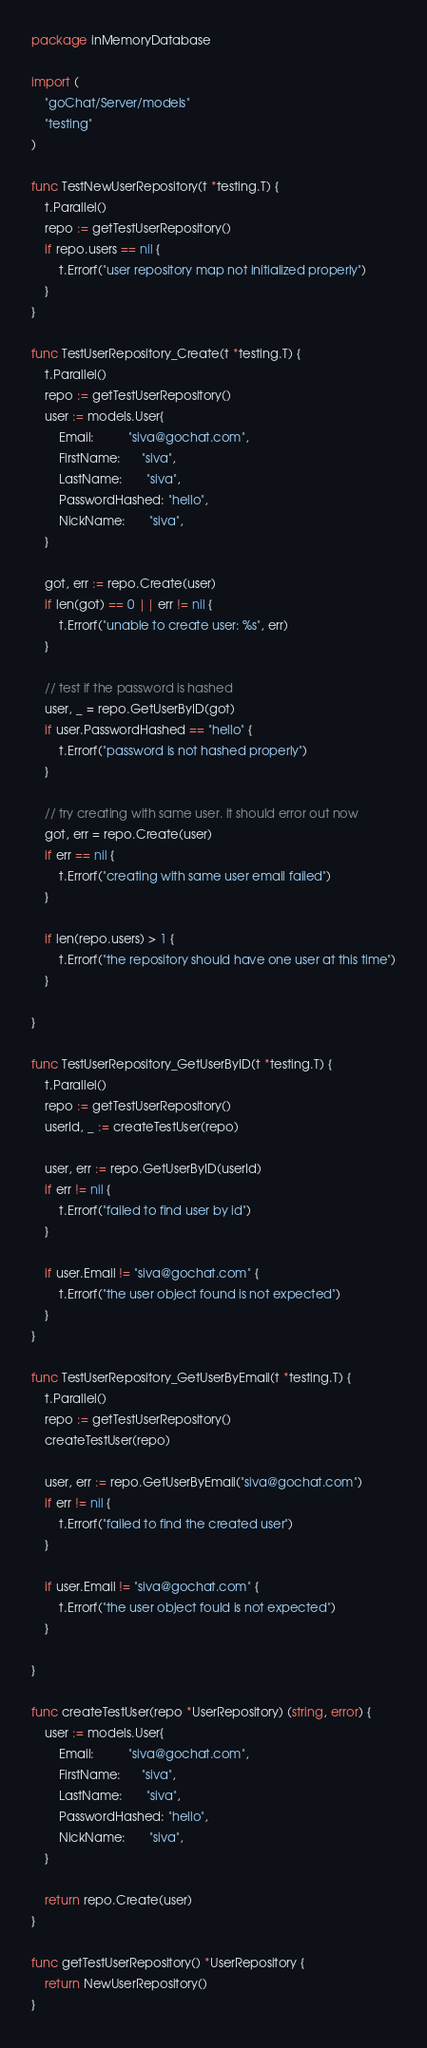Convert code to text. <code><loc_0><loc_0><loc_500><loc_500><_Go_>package inMemoryDatabase

import (
	"goChat/Server/models"
	"testing"
)

func TestNewUserRepository(t *testing.T) {
	t.Parallel()
	repo := getTestUserRepository()
	if repo.users == nil {
		t.Errorf("user repository map not initialized properly")
	}
}

func TestUserRepository_Create(t *testing.T) {
	t.Parallel()
	repo := getTestUserRepository()
	user := models.User{
		Email:          "siva@gochat.com",
		FirstName:      "siva",
		LastName:       "siva",
		PasswordHashed: "hello",
		NickName:       "siva",
	}

	got, err := repo.Create(user)
	if len(got) == 0 || err != nil {
		t.Errorf("unable to create user: %s", err)
	}

	// test if the password is hashed
	user, _ = repo.GetUserByID(got)
	if user.PasswordHashed == "hello" {
		t.Errorf("password is not hashed properly")
	}

	// try creating with same user. it should error out now
	got, err = repo.Create(user)
	if err == nil {
		t.Errorf("creating with same user email failed")
	}

	if len(repo.users) > 1 {
		t.Errorf("the repository should have one user at this time")
	}

}

func TestUserRepository_GetUserByID(t *testing.T) {
	t.Parallel()
	repo := getTestUserRepository()
	userId, _ := createTestUser(repo)

	user, err := repo.GetUserByID(userId)
	if err != nil {
		t.Errorf("failed to find user by id")
	}

	if user.Email != "siva@gochat.com" {
		t.Errorf("the user object found is not expected")
	}
}

func TestUserRepository_GetUserByEmail(t *testing.T) {
	t.Parallel()
	repo := getTestUserRepository()
	createTestUser(repo)

	user, err := repo.GetUserByEmail("siva@gochat.com")
	if err != nil {
		t.Errorf("failed to find the created user")
	}

	if user.Email != "siva@gochat.com" {
		t.Errorf("the user object fould is not expected")
	}

}

func createTestUser(repo *UserRepository) (string, error) {
	user := models.User{
		Email:          "siva@gochat.com",
		FirstName:      "siva",
		LastName:       "siva",
		PasswordHashed: "hello",
		NickName:       "siva",
	}

	return repo.Create(user)
}

func getTestUserRepository() *UserRepository {
	return NewUserRepository()
}
</code> 